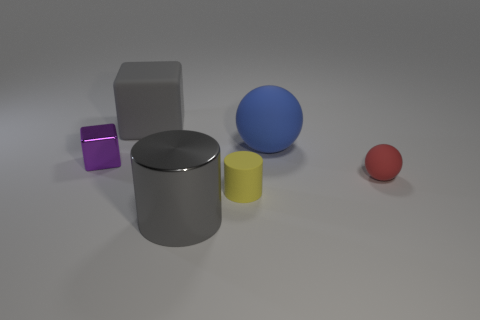Add 2 big matte spheres. How many objects exist? 8 Subtract all cubes. How many objects are left? 4 Subtract all tiny shiny things. Subtract all rubber cylinders. How many objects are left? 4 Add 2 matte cylinders. How many matte cylinders are left? 3 Add 4 large rubber objects. How many large rubber objects exist? 6 Subtract 1 yellow cylinders. How many objects are left? 5 